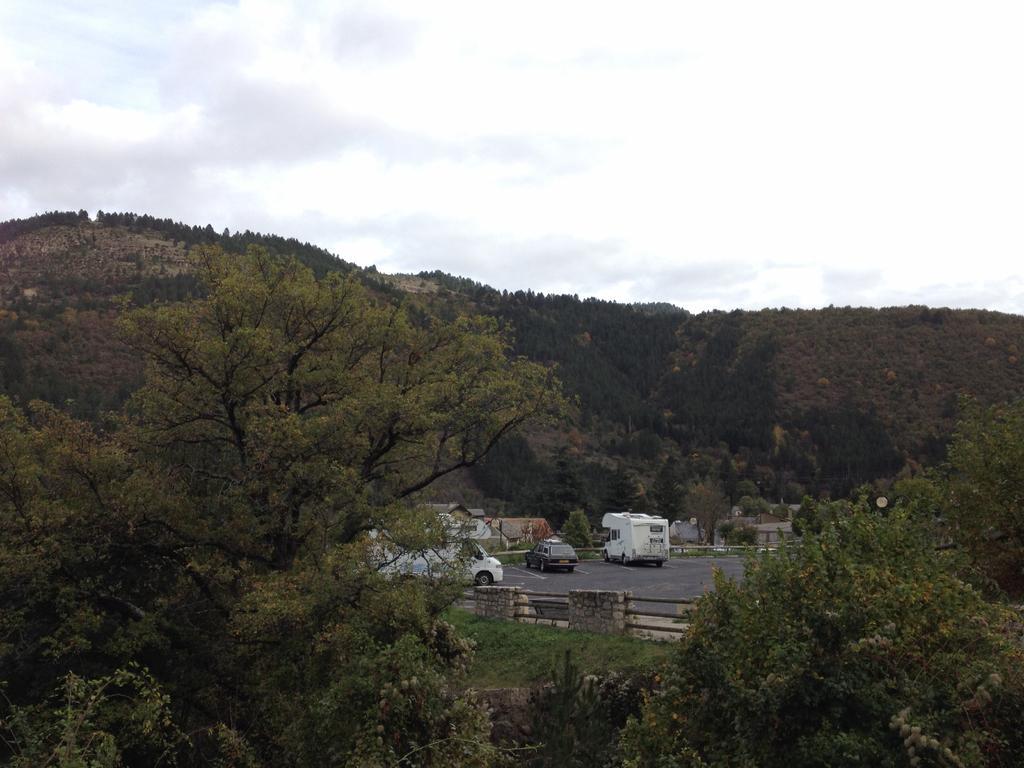Describe this image in one or two sentences. In this picture there are trees. Behind the trees there is a railing. There is grass on the ground. On the other side of the railing there is a road. There are vehicles on the road. Behind the vehicles there are mountains. There are trees on the mountains. At the top there is the sky. 